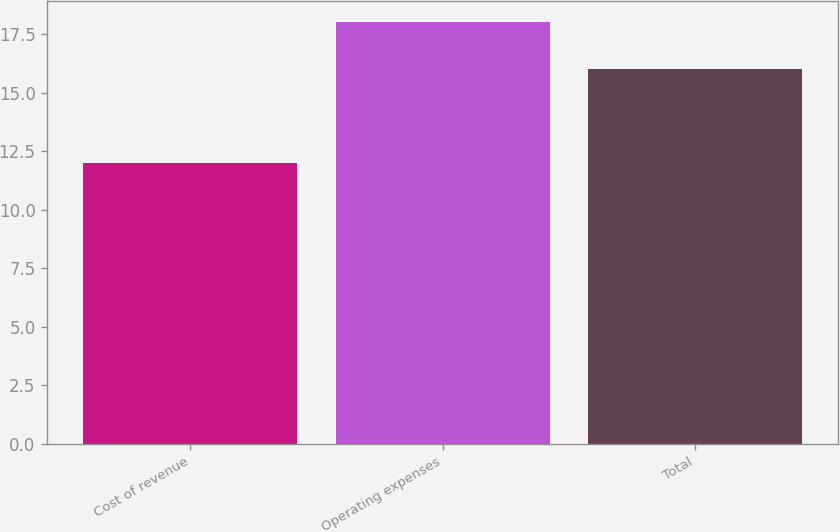Convert chart to OTSL. <chart><loc_0><loc_0><loc_500><loc_500><bar_chart><fcel>Cost of revenue<fcel>Operating expenses<fcel>Total<nl><fcel>12<fcel>18<fcel>16<nl></chart> 